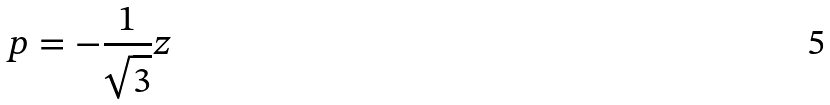<formula> <loc_0><loc_0><loc_500><loc_500>p = - \frac { 1 } { \sqrt { 3 } } z</formula> 